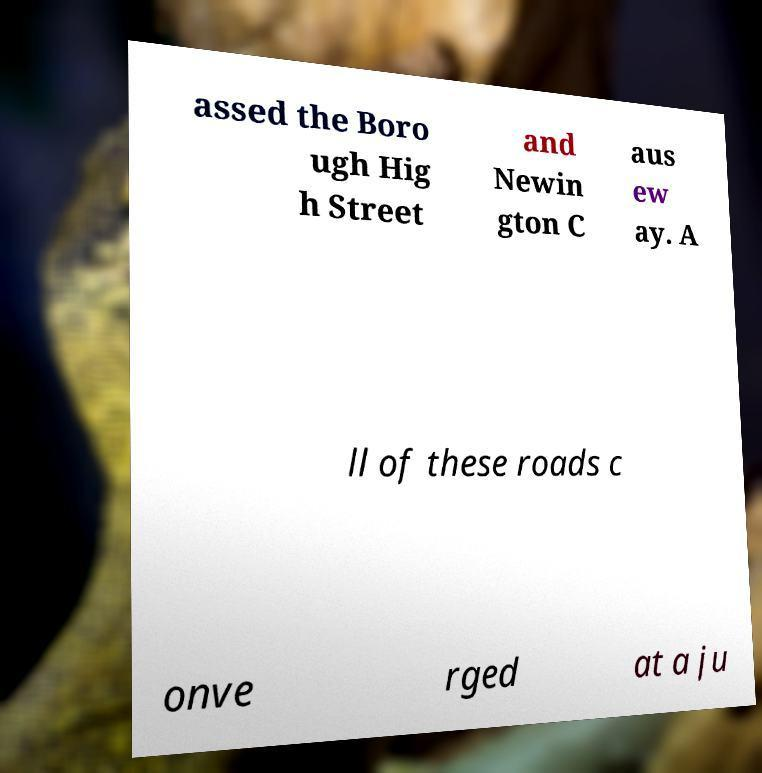For documentation purposes, I need the text within this image transcribed. Could you provide that? assed the Boro ugh Hig h Street and Newin gton C aus ew ay. A ll of these roads c onve rged at a ju 